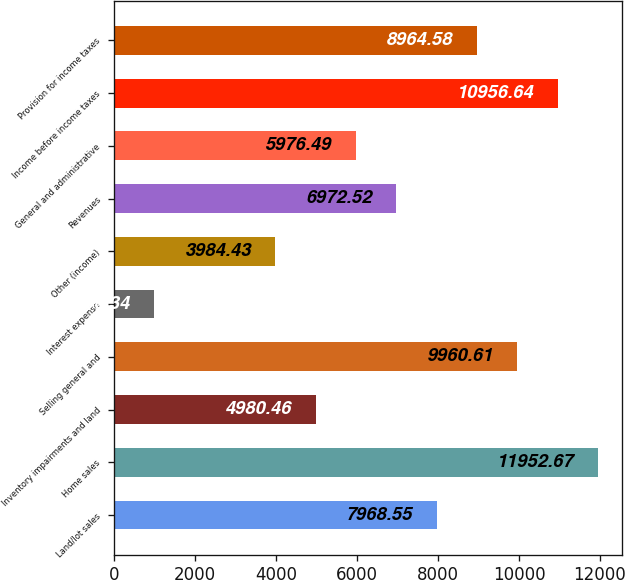<chart> <loc_0><loc_0><loc_500><loc_500><bar_chart><fcel>Land/lot sales<fcel>Home sales<fcel>Inventory impairments and land<fcel>Selling general and<fcel>Interest expense<fcel>Other (income)<fcel>Revenues<fcel>General and administrative<fcel>Income before income taxes<fcel>Provision for income taxes<nl><fcel>7968.55<fcel>11952.7<fcel>4980.46<fcel>9960.61<fcel>996.34<fcel>3984.43<fcel>6972.52<fcel>5976.49<fcel>10956.6<fcel>8964.58<nl></chart> 